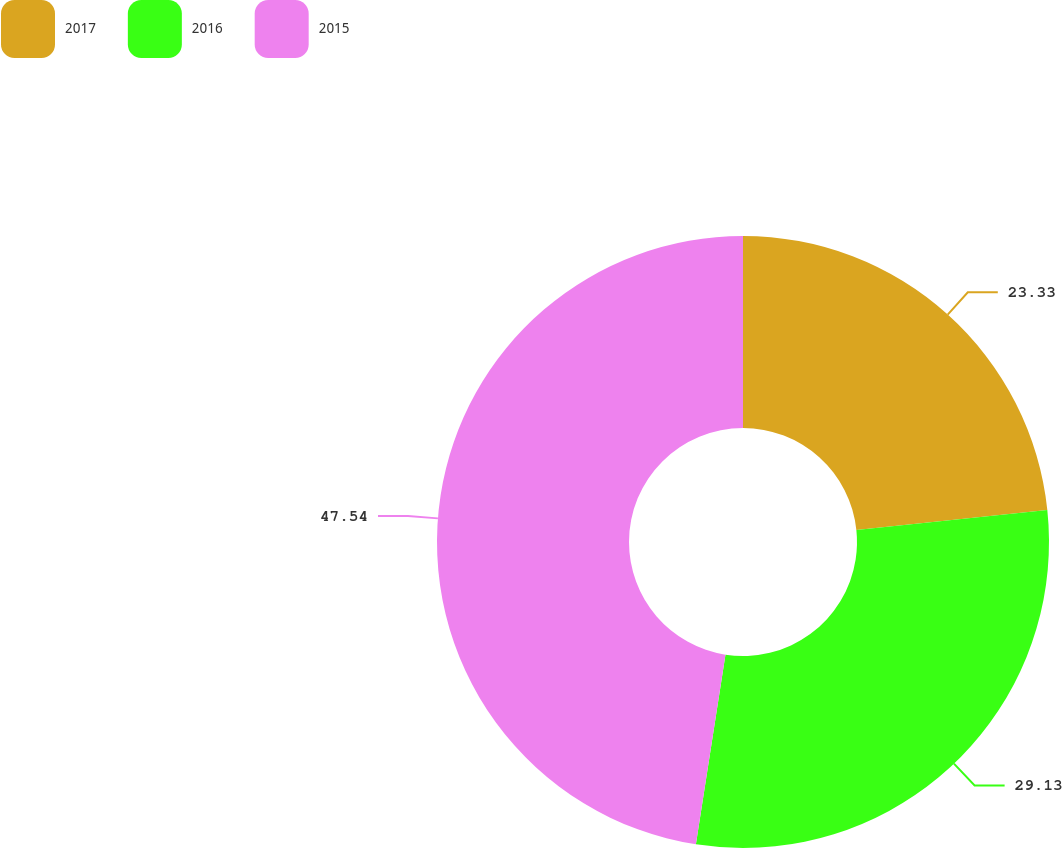Convert chart to OTSL. <chart><loc_0><loc_0><loc_500><loc_500><pie_chart><fcel>2017<fcel>2016<fcel>2015<nl><fcel>23.33%<fcel>29.13%<fcel>47.54%<nl></chart> 